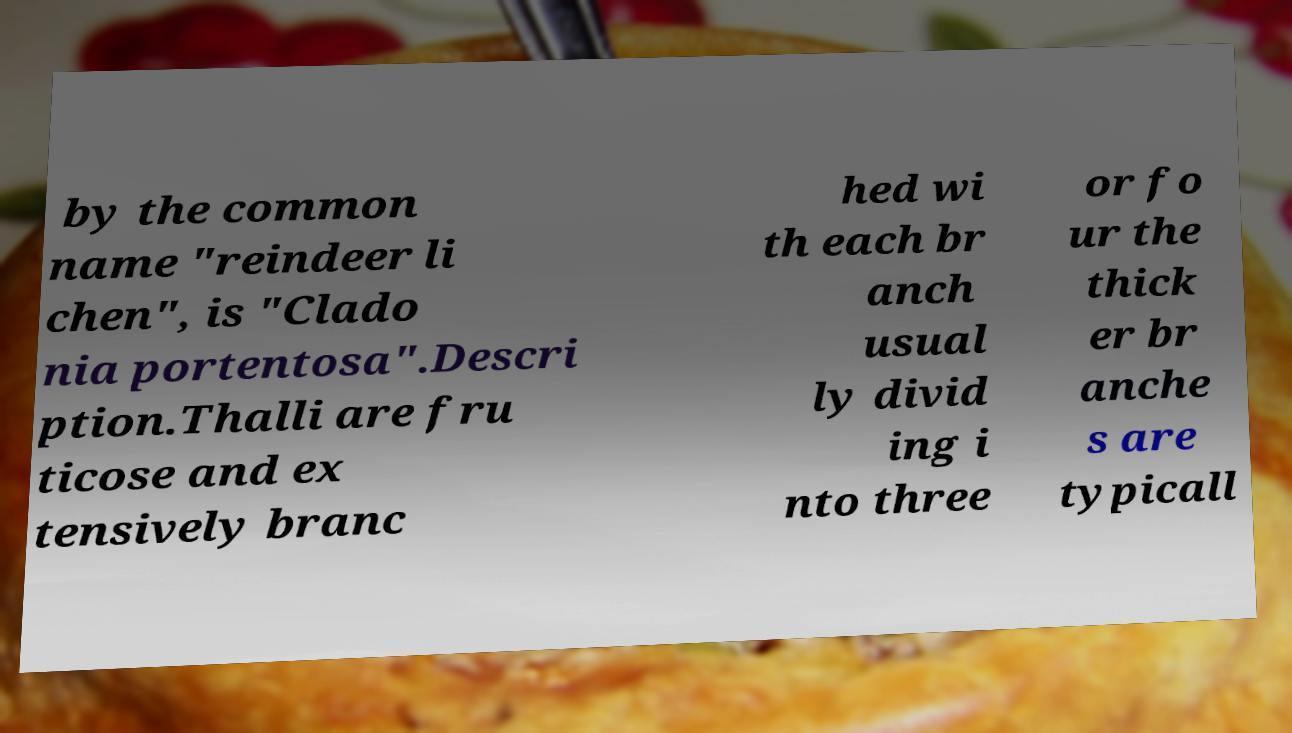Please identify and transcribe the text found in this image. by the common name "reindeer li chen", is "Clado nia portentosa".Descri ption.Thalli are fru ticose and ex tensively branc hed wi th each br anch usual ly divid ing i nto three or fo ur the thick er br anche s are typicall 